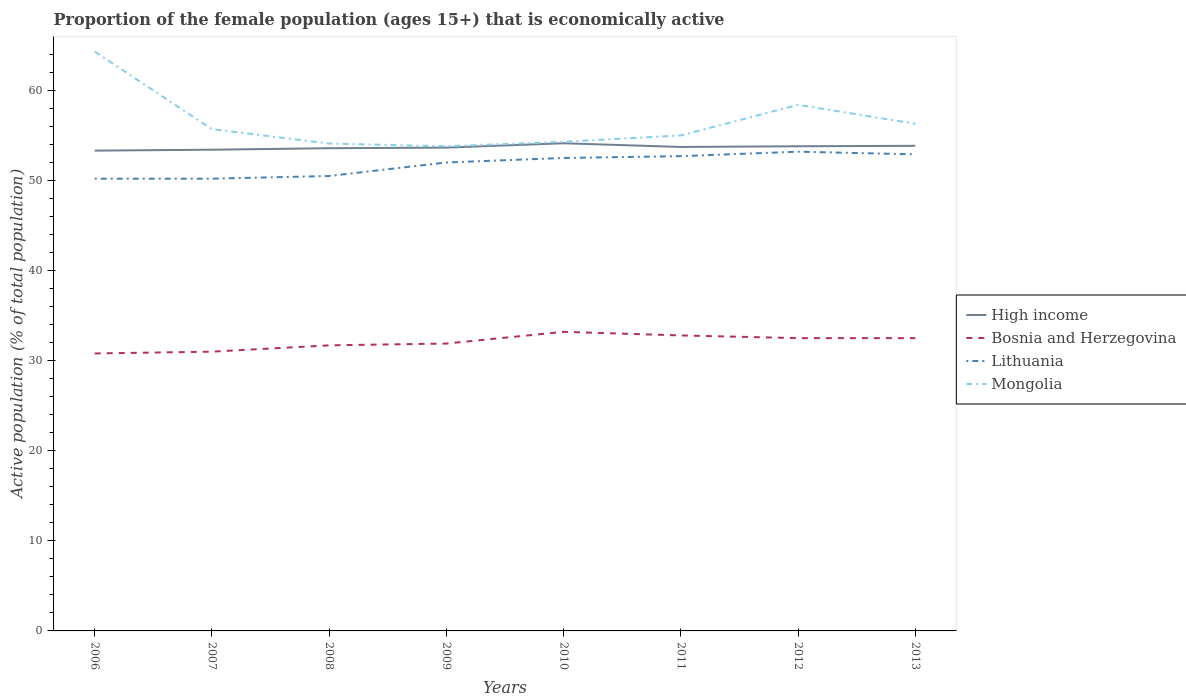How many different coloured lines are there?
Give a very brief answer. 4. Does the line corresponding to High income intersect with the line corresponding to Bosnia and Herzegovina?
Your answer should be compact. No. Across all years, what is the maximum proportion of the female population that is economically active in Bosnia and Herzegovina?
Provide a short and direct response. 30.8. In which year was the proportion of the female population that is economically active in Mongolia maximum?
Ensure brevity in your answer.  2009. What is the total proportion of the female population that is economically active in Mongolia in the graph?
Provide a succinct answer. -0.2. What is the difference between the highest and the second highest proportion of the female population that is economically active in High income?
Provide a succinct answer. 0.82. What is the difference between the highest and the lowest proportion of the female population that is economically active in High income?
Offer a very short reply. 4. Is the proportion of the female population that is economically active in Lithuania strictly greater than the proportion of the female population that is economically active in Bosnia and Herzegovina over the years?
Offer a terse response. No. How many lines are there?
Offer a terse response. 4. How many years are there in the graph?
Provide a short and direct response. 8. Where does the legend appear in the graph?
Make the answer very short. Center right. How many legend labels are there?
Keep it short and to the point. 4. How are the legend labels stacked?
Provide a short and direct response. Vertical. What is the title of the graph?
Ensure brevity in your answer.  Proportion of the female population (ages 15+) that is economically active. Does "Comoros" appear as one of the legend labels in the graph?
Your answer should be very brief. No. What is the label or title of the X-axis?
Keep it short and to the point. Years. What is the label or title of the Y-axis?
Your answer should be very brief. Active population (% of total population). What is the Active population (% of total population) of High income in 2006?
Offer a terse response. 53.31. What is the Active population (% of total population) in Bosnia and Herzegovina in 2006?
Offer a very short reply. 30.8. What is the Active population (% of total population) of Lithuania in 2006?
Your response must be concise. 50.2. What is the Active population (% of total population) of Mongolia in 2006?
Give a very brief answer. 64.3. What is the Active population (% of total population) in High income in 2007?
Provide a short and direct response. 53.42. What is the Active population (% of total population) in Lithuania in 2007?
Provide a short and direct response. 50.2. What is the Active population (% of total population) in Mongolia in 2007?
Your answer should be very brief. 55.7. What is the Active population (% of total population) in High income in 2008?
Your answer should be compact. 53.58. What is the Active population (% of total population) in Bosnia and Herzegovina in 2008?
Provide a short and direct response. 31.7. What is the Active population (% of total population) of Lithuania in 2008?
Your response must be concise. 50.5. What is the Active population (% of total population) in Mongolia in 2008?
Keep it short and to the point. 54.1. What is the Active population (% of total population) of High income in 2009?
Provide a succinct answer. 53.65. What is the Active population (% of total population) of Bosnia and Herzegovina in 2009?
Keep it short and to the point. 31.9. What is the Active population (% of total population) in Mongolia in 2009?
Keep it short and to the point. 53.8. What is the Active population (% of total population) in High income in 2010?
Provide a short and direct response. 54.13. What is the Active population (% of total population) of Bosnia and Herzegovina in 2010?
Your answer should be compact. 33.2. What is the Active population (% of total population) in Lithuania in 2010?
Keep it short and to the point. 52.5. What is the Active population (% of total population) of Mongolia in 2010?
Your answer should be very brief. 54.3. What is the Active population (% of total population) in High income in 2011?
Keep it short and to the point. 53.72. What is the Active population (% of total population) of Bosnia and Herzegovina in 2011?
Your response must be concise. 32.8. What is the Active population (% of total population) in Lithuania in 2011?
Your response must be concise. 52.7. What is the Active population (% of total population) of High income in 2012?
Make the answer very short. 53.8. What is the Active population (% of total population) of Bosnia and Herzegovina in 2012?
Offer a terse response. 32.5. What is the Active population (% of total population) of Lithuania in 2012?
Your answer should be very brief. 53.2. What is the Active population (% of total population) of Mongolia in 2012?
Offer a very short reply. 58.4. What is the Active population (% of total population) of High income in 2013?
Give a very brief answer. 53.85. What is the Active population (% of total population) of Bosnia and Herzegovina in 2013?
Keep it short and to the point. 32.5. What is the Active population (% of total population) in Lithuania in 2013?
Your response must be concise. 52.9. What is the Active population (% of total population) of Mongolia in 2013?
Make the answer very short. 56.3. Across all years, what is the maximum Active population (% of total population) in High income?
Make the answer very short. 54.13. Across all years, what is the maximum Active population (% of total population) in Bosnia and Herzegovina?
Ensure brevity in your answer.  33.2. Across all years, what is the maximum Active population (% of total population) in Lithuania?
Provide a succinct answer. 53.2. Across all years, what is the maximum Active population (% of total population) of Mongolia?
Your answer should be very brief. 64.3. Across all years, what is the minimum Active population (% of total population) in High income?
Your answer should be compact. 53.31. Across all years, what is the minimum Active population (% of total population) in Bosnia and Herzegovina?
Make the answer very short. 30.8. Across all years, what is the minimum Active population (% of total population) of Lithuania?
Ensure brevity in your answer.  50.2. Across all years, what is the minimum Active population (% of total population) of Mongolia?
Provide a succinct answer. 53.8. What is the total Active population (% of total population) in High income in the graph?
Your answer should be compact. 429.47. What is the total Active population (% of total population) of Bosnia and Herzegovina in the graph?
Provide a succinct answer. 256.4. What is the total Active population (% of total population) in Lithuania in the graph?
Offer a very short reply. 414.2. What is the total Active population (% of total population) of Mongolia in the graph?
Ensure brevity in your answer.  451.9. What is the difference between the Active population (% of total population) in High income in 2006 and that in 2007?
Offer a very short reply. -0.1. What is the difference between the Active population (% of total population) of Lithuania in 2006 and that in 2007?
Keep it short and to the point. 0. What is the difference between the Active population (% of total population) of High income in 2006 and that in 2008?
Provide a short and direct response. -0.27. What is the difference between the Active population (% of total population) of Bosnia and Herzegovina in 2006 and that in 2008?
Offer a terse response. -0.9. What is the difference between the Active population (% of total population) in Lithuania in 2006 and that in 2008?
Ensure brevity in your answer.  -0.3. What is the difference between the Active population (% of total population) of Mongolia in 2006 and that in 2008?
Offer a very short reply. 10.2. What is the difference between the Active population (% of total population) in High income in 2006 and that in 2009?
Your response must be concise. -0.34. What is the difference between the Active population (% of total population) in Bosnia and Herzegovina in 2006 and that in 2009?
Keep it short and to the point. -1.1. What is the difference between the Active population (% of total population) in Lithuania in 2006 and that in 2009?
Your response must be concise. -1.8. What is the difference between the Active population (% of total population) of High income in 2006 and that in 2010?
Keep it short and to the point. -0.82. What is the difference between the Active population (% of total population) of Bosnia and Herzegovina in 2006 and that in 2010?
Make the answer very short. -2.4. What is the difference between the Active population (% of total population) of Mongolia in 2006 and that in 2010?
Give a very brief answer. 10. What is the difference between the Active population (% of total population) in High income in 2006 and that in 2011?
Make the answer very short. -0.41. What is the difference between the Active population (% of total population) of Lithuania in 2006 and that in 2011?
Make the answer very short. -2.5. What is the difference between the Active population (% of total population) of Mongolia in 2006 and that in 2011?
Provide a succinct answer. 9.3. What is the difference between the Active population (% of total population) of High income in 2006 and that in 2012?
Ensure brevity in your answer.  -0.48. What is the difference between the Active population (% of total population) in Bosnia and Herzegovina in 2006 and that in 2012?
Ensure brevity in your answer.  -1.7. What is the difference between the Active population (% of total population) in High income in 2006 and that in 2013?
Offer a very short reply. -0.54. What is the difference between the Active population (% of total population) of Mongolia in 2006 and that in 2013?
Your answer should be very brief. 8. What is the difference between the Active population (% of total population) of High income in 2007 and that in 2008?
Your answer should be compact. -0.16. What is the difference between the Active population (% of total population) of Bosnia and Herzegovina in 2007 and that in 2008?
Give a very brief answer. -0.7. What is the difference between the Active population (% of total population) of Lithuania in 2007 and that in 2008?
Your answer should be very brief. -0.3. What is the difference between the Active population (% of total population) in High income in 2007 and that in 2009?
Offer a terse response. -0.23. What is the difference between the Active population (% of total population) of Bosnia and Herzegovina in 2007 and that in 2009?
Give a very brief answer. -0.9. What is the difference between the Active population (% of total population) in Lithuania in 2007 and that in 2009?
Ensure brevity in your answer.  -1.8. What is the difference between the Active population (% of total population) in High income in 2007 and that in 2010?
Offer a terse response. -0.71. What is the difference between the Active population (% of total population) of Bosnia and Herzegovina in 2007 and that in 2010?
Make the answer very short. -2.2. What is the difference between the Active population (% of total population) in Lithuania in 2007 and that in 2010?
Offer a very short reply. -2.3. What is the difference between the Active population (% of total population) in Mongolia in 2007 and that in 2010?
Keep it short and to the point. 1.4. What is the difference between the Active population (% of total population) in High income in 2007 and that in 2011?
Offer a terse response. -0.3. What is the difference between the Active population (% of total population) in Lithuania in 2007 and that in 2011?
Ensure brevity in your answer.  -2.5. What is the difference between the Active population (% of total population) in High income in 2007 and that in 2012?
Offer a terse response. -0.38. What is the difference between the Active population (% of total population) of High income in 2007 and that in 2013?
Your answer should be very brief. -0.43. What is the difference between the Active population (% of total population) in High income in 2008 and that in 2009?
Offer a very short reply. -0.07. What is the difference between the Active population (% of total population) of Bosnia and Herzegovina in 2008 and that in 2009?
Ensure brevity in your answer.  -0.2. What is the difference between the Active population (% of total population) of Lithuania in 2008 and that in 2009?
Your response must be concise. -1.5. What is the difference between the Active population (% of total population) in High income in 2008 and that in 2010?
Offer a terse response. -0.55. What is the difference between the Active population (% of total population) in Bosnia and Herzegovina in 2008 and that in 2010?
Provide a succinct answer. -1.5. What is the difference between the Active population (% of total population) in Lithuania in 2008 and that in 2010?
Make the answer very short. -2. What is the difference between the Active population (% of total population) of High income in 2008 and that in 2011?
Your answer should be very brief. -0.14. What is the difference between the Active population (% of total population) of Bosnia and Herzegovina in 2008 and that in 2011?
Your response must be concise. -1.1. What is the difference between the Active population (% of total population) of Lithuania in 2008 and that in 2011?
Keep it short and to the point. -2.2. What is the difference between the Active population (% of total population) of Mongolia in 2008 and that in 2011?
Your answer should be compact. -0.9. What is the difference between the Active population (% of total population) of High income in 2008 and that in 2012?
Offer a very short reply. -0.22. What is the difference between the Active population (% of total population) of High income in 2008 and that in 2013?
Offer a terse response. -0.27. What is the difference between the Active population (% of total population) in Bosnia and Herzegovina in 2008 and that in 2013?
Offer a terse response. -0.8. What is the difference between the Active population (% of total population) of High income in 2009 and that in 2010?
Your answer should be very brief. -0.48. What is the difference between the Active population (% of total population) in Mongolia in 2009 and that in 2010?
Give a very brief answer. -0.5. What is the difference between the Active population (% of total population) of High income in 2009 and that in 2011?
Make the answer very short. -0.07. What is the difference between the Active population (% of total population) of Bosnia and Herzegovina in 2009 and that in 2011?
Give a very brief answer. -0.9. What is the difference between the Active population (% of total population) in Lithuania in 2009 and that in 2011?
Offer a very short reply. -0.7. What is the difference between the Active population (% of total population) in High income in 2009 and that in 2012?
Your response must be concise. -0.15. What is the difference between the Active population (% of total population) of Mongolia in 2009 and that in 2012?
Your answer should be compact. -4.6. What is the difference between the Active population (% of total population) of High income in 2009 and that in 2013?
Your answer should be compact. -0.2. What is the difference between the Active population (% of total population) in Bosnia and Herzegovina in 2009 and that in 2013?
Ensure brevity in your answer.  -0.6. What is the difference between the Active population (% of total population) of High income in 2010 and that in 2011?
Provide a succinct answer. 0.41. What is the difference between the Active population (% of total population) in Bosnia and Herzegovina in 2010 and that in 2011?
Give a very brief answer. 0.4. What is the difference between the Active population (% of total population) in Lithuania in 2010 and that in 2011?
Your answer should be very brief. -0.2. What is the difference between the Active population (% of total population) in High income in 2010 and that in 2012?
Offer a very short reply. 0.33. What is the difference between the Active population (% of total population) of Bosnia and Herzegovina in 2010 and that in 2012?
Give a very brief answer. 0.7. What is the difference between the Active population (% of total population) of Mongolia in 2010 and that in 2012?
Make the answer very short. -4.1. What is the difference between the Active population (% of total population) in High income in 2010 and that in 2013?
Ensure brevity in your answer.  0.28. What is the difference between the Active population (% of total population) of Bosnia and Herzegovina in 2010 and that in 2013?
Keep it short and to the point. 0.7. What is the difference between the Active population (% of total population) in High income in 2011 and that in 2012?
Make the answer very short. -0.08. What is the difference between the Active population (% of total population) in Mongolia in 2011 and that in 2012?
Provide a short and direct response. -3.4. What is the difference between the Active population (% of total population) of High income in 2011 and that in 2013?
Your response must be concise. -0.13. What is the difference between the Active population (% of total population) of Bosnia and Herzegovina in 2011 and that in 2013?
Offer a very short reply. 0.3. What is the difference between the Active population (% of total population) of Lithuania in 2011 and that in 2013?
Make the answer very short. -0.2. What is the difference between the Active population (% of total population) in Mongolia in 2011 and that in 2013?
Your answer should be compact. -1.3. What is the difference between the Active population (% of total population) of High income in 2012 and that in 2013?
Your answer should be compact. -0.05. What is the difference between the Active population (% of total population) in Bosnia and Herzegovina in 2012 and that in 2013?
Your answer should be compact. 0. What is the difference between the Active population (% of total population) of Lithuania in 2012 and that in 2013?
Offer a very short reply. 0.3. What is the difference between the Active population (% of total population) of High income in 2006 and the Active population (% of total population) of Bosnia and Herzegovina in 2007?
Ensure brevity in your answer.  22.31. What is the difference between the Active population (% of total population) of High income in 2006 and the Active population (% of total population) of Lithuania in 2007?
Your response must be concise. 3.11. What is the difference between the Active population (% of total population) in High income in 2006 and the Active population (% of total population) in Mongolia in 2007?
Make the answer very short. -2.39. What is the difference between the Active population (% of total population) of Bosnia and Herzegovina in 2006 and the Active population (% of total population) of Lithuania in 2007?
Give a very brief answer. -19.4. What is the difference between the Active population (% of total population) in Bosnia and Herzegovina in 2006 and the Active population (% of total population) in Mongolia in 2007?
Ensure brevity in your answer.  -24.9. What is the difference between the Active population (% of total population) in High income in 2006 and the Active population (% of total population) in Bosnia and Herzegovina in 2008?
Make the answer very short. 21.61. What is the difference between the Active population (% of total population) in High income in 2006 and the Active population (% of total population) in Lithuania in 2008?
Provide a succinct answer. 2.81. What is the difference between the Active population (% of total population) in High income in 2006 and the Active population (% of total population) in Mongolia in 2008?
Ensure brevity in your answer.  -0.79. What is the difference between the Active population (% of total population) of Bosnia and Herzegovina in 2006 and the Active population (% of total population) of Lithuania in 2008?
Your answer should be compact. -19.7. What is the difference between the Active population (% of total population) in Bosnia and Herzegovina in 2006 and the Active population (% of total population) in Mongolia in 2008?
Make the answer very short. -23.3. What is the difference between the Active population (% of total population) of Lithuania in 2006 and the Active population (% of total population) of Mongolia in 2008?
Give a very brief answer. -3.9. What is the difference between the Active population (% of total population) of High income in 2006 and the Active population (% of total population) of Bosnia and Herzegovina in 2009?
Offer a very short reply. 21.41. What is the difference between the Active population (% of total population) in High income in 2006 and the Active population (% of total population) in Lithuania in 2009?
Provide a succinct answer. 1.31. What is the difference between the Active population (% of total population) in High income in 2006 and the Active population (% of total population) in Mongolia in 2009?
Ensure brevity in your answer.  -0.49. What is the difference between the Active population (% of total population) in Bosnia and Herzegovina in 2006 and the Active population (% of total population) in Lithuania in 2009?
Provide a short and direct response. -21.2. What is the difference between the Active population (% of total population) in High income in 2006 and the Active population (% of total population) in Bosnia and Herzegovina in 2010?
Provide a short and direct response. 20.11. What is the difference between the Active population (% of total population) in High income in 2006 and the Active population (% of total population) in Lithuania in 2010?
Provide a short and direct response. 0.81. What is the difference between the Active population (% of total population) in High income in 2006 and the Active population (% of total population) in Mongolia in 2010?
Your answer should be compact. -0.99. What is the difference between the Active population (% of total population) in Bosnia and Herzegovina in 2006 and the Active population (% of total population) in Lithuania in 2010?
Ensure brevity in your answer.  -21.7. What is the difference between the Active population (% of total population) of Bosnia and Herzegovina in 2006 and the Active population (% of total population) of Mongolia in 2010?
Ensure brevity in your answer.  -23.5. What is the difference between the Active population (% of total population) in Lithuania in 2006 and the Active population (% of total population) in Mongolia in 2010?
Provide a succinct answer. -4.1. What is the difference between the Active population (% of total population) of High income in 2006 and the Active population (% of total population) of Bosnia and Herzegovina in 2011?
Make the answer very short. 20.51. What is the difference between the Active population (% of total population) of High income in 2006 and the Active population (% of total population) of Lithuania in 2011?
Keep it short and to the point. 0.61. What is the difference between the Active population (% of total population) of High income in 2006 and the Active population (% of total population) of Mongolia in 2011?
Your answer should be compact. -1.69. What is the difference between the Active population (% of total population) of Bosnia and Herzegovina in 2006 and the Active population (% of total population) of Lithuania in 2011?
Offer a terse response. -21.9. What is the difference between the Active population (% of total population) of Bosnia and Herzegovina in 2006 and the Active population (% of total population) of Mongolia in 2011?
Keep it short and to the point. -24.2. What is the difference between the Active population (% of total population) of High income in 2006 and the Active population (% of total population) of Bosnia and Herzegovina in 2012?
Provide a succinct answer. 20.81. What is the difference between the Active population (% of total population) of High income in 2006 and the Active population (% of total population) of Lithuania in 2012?
Give a very brief answer. 0.11. What is the difference between the Active population (% of total population) in High income in 2006 and the Active population (% of total population) in Mongolia in 2012?
Your answer should be very brief. -5.09. What is the difference between the Active population (% of total population) of Bosnia and Herzegovina in 2006 and the Active population (% of total population) of Lithuania in 2012?
Your response must be concise. -22.4. What is the difference between the Active population (% of total population) of Bosnia and Herzegovina in 2006 and the Active population (% of total population) of Mongolia in 2012?
Provide a succinct answer. -27.6. What is the difference between the Active population (% of total population) of High income in 2006 and the Active population (% of total population) of Bosnia and Herzegovina in 2013?
Your response must be concise. 20.81. What is the difference between the Active population (% of total population) of High income in 2006 and the Active population (% of total population) of Lithuania in 2013?
Keep it short and to the point. 0.41. What is the difference between the Active population (% of total population) of High income in 2006 and the Active population (% of total population) of Mongolia in 2013?
Offer a very short reply. -2.99. What is the difference between the Active population (% of total population) of Bosnia and Herzegovina in 2006 and the Active population (% of total population) of Lithuania in 2013?
Your answer should be very brief. -22.1. What is the difference between the Active population (% of total population) in Bosnia and Herzegovina in 2006 and the Active population (% of total population) in Mongolia in 2013?
Offer a terse response. -25.5. What is the difference between the Active population (% of total population) in Lithuania in 2006 and the Active population (% of total population) in Mongolia in 2013?
Your response must be concise. -6.1. What is the difference between the Active population (% of total population) of High income in 2007 and the Active population (% of total population) of Bosnia and Herzegovina in 2008?
Make the answer very short. 21.72. What is the difference between the Active population (% of total population) of High income in 2007 and the Active population (% of total population) of Lithuania in 2008?
Make the answer very short. 2.92. What is the difference between the Active population (% of total population) in High income in 2007 and the Active population (% of total population) in Mongolia in 2008?
Your answer should be very brief. -0.68. What is the difference between the Active population (% of total population) in Bosnia and Herzegovina in 2007 and the Active population (% of total population) in Lithuania in 2008?
Your response must be concise. -19.5. What is the difference between the Active population (% of total population) in Bosnia and Herzegovina in 2007 and the Active population (% of total population) in Mongolia in 2008?
Give a very brief answer. -23.1. What is the difference between the Active population (% of total population) of Lithuania in 2007 and the Active population (% of total population) of Mongolia in 2008?
Your response must be concise. -3.9. What is the difference between the Active population (% of total population) in High income in 2007 and the Active population (% of total population) in Bosnia and Herzegovina in 2009?
Make the answer very short. 21.52. What is the difference between the Active population (% of total population) in High income in 2007 and the Active population (% of total population) in Lithuania in 2009?
Offer a terse response. 1.42. What is the difference between the Active population (% of total population) in High income in 2007 and the Active population (% of total population) in Mongolia in 2009?
Offer a terse response. -0.38. What is the difference between the Active population (% of total population) of Bosnia and Herzegovina in 2007 and the Active population (% of total population) of Mongolia in 2009?
Provide a succinct answer. -22.8. What is the difference between the Active population (% of total population) in High income in 2007 and the Active population (% of total population) in Bosnia and Herzegovina in 2010?
Your response must be concise. 20.22. What is the difference between the Active population (% of total population) in High income in 2007 and the Active population (% of total population) in Lithuania in 2010?
Offer a very short reply. 0.92. What is the difference between the Active population (% of total population) in High income in 2007 and the Active population (% of total population) in Mongolia in 2010?
Your answer should be compact. -0.88. What is the difference between the Active population (% of total population) in Bosnia and Herzegovina in 2007 and the Active population (% of total population) in Lithuania in 2010?
Your response must be concise. -21.5. What is the difference between the Active population (% of total population) in Bosnia and Herzegovina in 2007 and the Active population (% of total population) in Mongolia in 2010?
Provide a succinct answer. -23.3. What is the difference between the Active population (% of total population) of Lithuania in 2007 and the Active population (% of total population) of Mongolia in 2010?
Give a very brief answer. -4.1. What is the difference between the Active population (% of total population) of High income in 2007 and the Active population (% of total population) of Bosnia and Herzegovina in 2011?
Offer a very short reply. 20.62. What is the difference between the Active population (% of total population) in High income in 2007 and the Active population (% of total population) in Lithuania in 2011?
Make the answer very short. 0.72. What is the difference between the Active population (% of total population) in High income in 2007 and the Active population (% of total population) in Mongolia in 2011?
Keep it short and to the point. -1.58. What is the difference between the Active population (% of total population) in Bosnia and Herzegovina in 2007 and the Active population (% of total population) in Lithuania in 2011?
Give a very brief answer. -21.7. What is the difference between the Active population (% of total population) of Bosnia and Herzegovina in 2007 and the Active population (% of total population) of Mongolia in 2011?
Offer a very short reply. -24. What is the difference between the Active population (% of total population) in High income in 2007 and the Active population (% of total population) in Bosnia and Herzegovina in 2012?
Give a very brief answer. 20.92. What is the difference between the Active population (% of total population) in High income in 2007 and the Active population (% of total population) in Lithuania in 2012?
Your answer should be very brief. 0.22. What is the difference between the Active population (% of total population) in High income in 2007 and the Active population (% of total population) in Mongolia in 2012?
Ensure brevity in your answer.  -4.98. What is the difference between the Active population (% of total population) in Bosnia and Herzegovina in 2007 and the Active population (% of total population) in Lithuania in 2012?
Your answer should be very brief. -22.2. What is the difference between the Active population (% of total population) of Bosnia and Herzegovina in 2007 and the Active population (% of total population) of Mongolia in 2012?
Your response must be concise. -27.4. What is the difference between the Active population (% of total population) of High income in 2007 and the Active population (% of total population) of Bosnia and Herzegovina in 2013?
Provide a succinct answer. 20.92. What is the difference between the Active population (% of total population) in High income in 2007 and the Active population (% of total population) in Lithuania in 2013?
Offer a very short reply. 0.52. What is the difference between the Active population (% of total population) in High income in 2007 and the Active population (% of total population) in Mongolia in 2013?
Make the answer very short. -2.88. What is the difference between the Active population (% of total population) in Bosnia and Herzegovina in 2007 and the Active population (% of total population) in Lithuania in 2013?
Offer a very short reply. -21.9. What is the difference between the Active population (% of total population) of Bosnia and Herzegovina in 2007 and the Active population (% of total population) of Mongolia in 2013?
Your response must be concise. -25.3. What is the difference between the Active population (% of total population) in High income in 2008 and the Active population (% of total population) in Bosnia and Herzegovina in 2009?
Provide a short and direct response. 21.68. What is the difference between the Active population (% of total population) of High income in 2008 and the Active population (% of total population) of Lithuania in 2009?
Offer a very short reply. 1.58. What is the difference between the Active population (% of total population) in High income in 2008 and the Active population (% of total population) in Mongolia in 2009?
Keep it short and to the point. -0.22. What is the difference between the Active population (% of total population) of Bosnia and Herzegovina in 2008 and the Active population (% of total population) of Lithuania in 2009?
Offer a terse response. -20.3. What is the difference between the Active population (% of total population) of Bosnia and Herzegovina in 2008 and the Active population (% of total population) of Mongolia in 2009?
Ensure brevity in your answer.  -22.1. What is the difference between the Active population (% of total population) in Lithuania in 2008 and the Active population (% of total population) in Mongolia in 2009?
Make the answer very short. -3.3. What is the difference between the Active population (% of total population) in High income in 2008 and the Active population (% of total population) in Bosnia and Herzegovina in 2010?
Offer a very short reply. 20.38. What is the difference between the Active population (% of total population) of High income in 2008 and the Active population (% of total population) of Lithuania in 2010?
Give a very brief answer. 1.08. What is the difference between the Active population (% of total population) of High income in 2008 and the Active population (% of total population) of Mongolia in 2010?
Give a very brief answer. -0.72. What is the difference between the Active population (% of total population) of Bosnia and Herzegovina in 2008 and the Active population (% of total population) of Lithuania in 2010?
Provide a short and direct response. -20.8. What is the difference between the Active population (% of total population) of Bosnia and Herzegovina in 2008 and the Active population (% of total population) of Mongolia in 2010?
Provide a short and direct response. -22.6. What is the difference between the Active population (% of total population) in Lithuania in 2008 and the Active population (% of total population) in Mongolia in 2010?
Keep it short and to the point. -3.8. What is the difference between the Active population (% of total population) in High income in 2008 and the Active population (% of total population) in Bosnia and Herzegovina in 2011?
Your answer should be compact. 20.78. What is the difference between the Active population (% of total population) in High income in 2008 and the Active population (% of total population) in Lithuania in 2011?
Give a very brief answer. 0.88. What is the difference between the Active population (% of total population) of High income in 2008 and the Active population (% of total population) of Mongolia in 2011?
Give a very brief answer. -1.42. What is the difference between the Active population (% of total population) in Bosnia and Herzegovina in 2008 and the Active population (% of total population) in Mongolia in 2011?
Offer a very short reply. -23.3. What is the difference between the Active population (% of total population) in High income in 2008 and the Active population (% of total population) in Bosnia and Herzegovina in 2012?
Provide a short and direct response. 21.08. What is the difference between the Active population (% of total population) in High income in 2008 and the Active population (% of total population) in Lithuania in 2012?
Provide a succinct answer. 0.38. What is the difference between the Active population (% of total population) of High income in 2008 and the Active population (% of total population) of Mongolia in 2012?
Offer a terse response. -4.82. What is the difference between the Active population (% of total population) of Bosnia and Herzegovina in 2008 and the Active population (% of total population) of Lithuania in 2012?
Your answer should be very brief. -21.5. What is the difference between the Active population (% of total population) in Bosnia and Herzegovina in 2008 and the Active population (% of total population) in Mongolia in 2012?
Your response must be concise. -26.7. What is the difference between the Active population (% of total population) in High income in 2008 and the Active population (% of total population) in Bosnia and Herzegovina in 2013?
Keep it short and to the point. 21.08. What is the difference between the Active population (% of total population) in High income in 2008 and the Active population (% of total population) in Lithuania in 2013?
Your answer should be compact. 0.68. What is the difference between the Active population (% of total population) of High income in 2008 and the Active population (% of total population) of Mongolia in 2013?
Make the answer very short. -2.72. What is the difference between the Active population (% of total population) of Bosnia and Herzegovina in 2008 and the Active population (% of total population) of Lithuania in 2013?
Give a very brief answer. -21.2. What is the difference between the Active population (% of total population) of Bosnia and Herzegovina in 2008 and the Active population (% of total population) of Mongolia in 2013?
Your response must be concise. -24.6. What is the difference between the Active population (% of total population) in High income in 2009 and the Active population (% of total population) in Bosnia and Herzegovina in 2010?
Your answer should be compact. 20.45. What is the difference between the Active population (% of total population) in High income in 2009 and the Active population (% of total population) in Lithuania in 2010?
Your answer should be compact. 1.15. What is the difference between the Active population (% of total population) in High income in 2009 and the Active population (% of total population) in Mongolia in 2010?
Make the answer very short. -0.65. What is the difference between the Active population (% of total population) of Bosnia and Herzegovina in 2009 and the Active population (% of total population) of Lithuania in 2010?
Provide a succinct answer. -20.6. What is the difference between the Active population (% of total population) of Bosnia and Herzegovina in 2009 and the Active population (% of total population) of Mongolia in 2010?
Your answer should be very brief. -22.4. What is the difference between the Active population (% of total population) of Lithuania in 2009 and the Active population (% of total population) of Mongolia in 2010?
Provide a succinct answer. -2.3. What is the difference between the Active population (% of total population) of High income in 2009 and the Active population (% of total population) of Bosnia and Herzegovina in 2011?
Give a very brief answer. 20.85. What is the difference between the Active population (% of total population) in High income in 2009 and the Active population (% of total population) in Lithuania in 2011?
Keep it short and to the point. 0.95. What is the difference between the Active population (% of total population) in High income in 2009 and the Active population (% of total population) in Mongolia in 2011?
Offer a very short reply. -1.35. What is the difference between the Active population (% of total population) of Bosnia and Herzegovina in 2009 and the Active population (% of total population) of Lithuania in 2011?
Give a very brief answer. -20.8. What is the difference between the Active population (% of total population) in Bosnia and Herzegovina in 2009 and the Active population (% of total population) in Mongolia in 2011?
Your answer should be very brief. -23.1. What is the difference between the Active population (% of total population) of Lithuania in 2009 and the Active population (% of total population) of Mongolia in 2011?
Your answer should be very brief. -3. What is the difference between the Active population (% of total population) of High income in 2009 and the Active population (% of total population) of Bosnia and Herzegovina in 2012?
Keep it short and to the point. 21.15. What is the difference between the Active population (% of total population) of High income in 2009 and the Active population (% of total population) of Lithuania in 2012?
Make the answer very short. 0.45. What is the difference between the Active population (% of total population) in High income in 2009 and the Active population (% of total population) in Mongolia in 2012?
Your response must be concise. -4.75. What is the difference between the Active population (% of total population) of Bosnia and Herzegovina in 2009 and the Active population (% of total population) of Lithuania in 2012?
Ensure brevity in your answer.  -21.3. What is the difference between the Active population (% of total population) in Bosnia and Herzegovina in 2009 and the Active population (% of total population) in Mongolia in 2012?
Make the answer very short. -26.5. What is the difference between the Active population (% of total population) in Lithuania in 2009 and the Active population (% of total population) in Mongolia in 2012?
Provide a short and direct response. -6.4. What is the difference between the Active population (% of total population) of High income in 2009 and the Active population (% of total population) of Bosnia and Herzegovina in 2013?
Make the answer very short. 21.15. What is the difference between the Active population (% of total population) of High income in 2009 and the Active population (% of total population) of Lithuania in 2013?
Ensure brevity in your answer.  0.75. What is the difference between the Active population (% of total population) of High income in 2009 and the Active population (% of total population) of Mongolia in 2013?
Offer a terse response. -2.65. What is the difference between the Active population (% of total population) of Bosnia and Herzegovina in 2009 and the Active population (% of total population) of Mongolia in 2013?
Give a very brief answer. -24.4. What is the difference between the Active population (% of total population) in High income in 2010 and the Active population (% of total population) in Bosnia and Herzegovina in 2011?
Offer a very short reply. 21.33. What is the difference between the Active population (% of total population) in High income in 2010 and the Active population (% of total population) in Lithuania in 2011?
Ensure brevity in your answer.  1.43. What is the difference between the Active population (% of total population) of High income in 2010 and the Active population (% of total population) of Mongolia in 2011?
Provide a short and direct response. -0.87. What is the difference between the Active population (% of total population) in Bosnia and Herzegovina in 2010 and the Active population (% of total population) in Lithuania in 2011?
Offer a terse response. -19.5. What is the difference between the Active population (% of total population) in Bosnia and Herzegovina in 2010 and the Active population (% of total population) in Mongolia in 2011?
Your answer should be compact. -21.8. What is the difference between the Active population (% of total population) of Lithuania in 2010 and the Active population (% of total population) of Mongolia in 2011?
Offer a very short reply. -2.5. What is the difference between the Active population (% of total population) of High income in 2010 and the Active population (% of total population) of Bosnia and Herzegovina in 2012?
Your answer should be very brief. 21.63. What is the difference between the Active population (% of total population) of High income in 2010 and the Active population (% of total population) of Lithuania in 2012?
Your response must be concise. 0.93. What is the difference between the Active population (% of total population) of High income in 2010 and the Active population (% of total population) of Mongolia in 2012?
Provide a succinct answer. -4.27. What is the difference between the Active population (% of total population) of Bosnia and Herzegovina in 2010 and the Active population (% of total population) of Lithuania in 2012?
Offer a very short reply. -20. What is the difference between the Active population (% of total population) in Bosnia and Herzegovina in 2010 and the Active population (% of total population) in Mongolia in 2012?
Offer a terse response. -25.2. What is the difference between the Active population (% of total population) of High income in 2010 and the Active population (% of total population) of Bosnia and Herzegovina in 2013?
Your answer should be compact. 21.63. What is the difference between the Active population (% of total population) of High income in 2010 and the Active population (% of total population) of Lithuania in 2013?
Keep it short and to the point. 1.23. What is the difference between the Active population (% of total population) of High income in 2010 and the Active population (% of total population) of Mongolia in 2013?
Give a very brief answer. -2.17. What is the difference between the Active population (% of total population) of Bosnia and Herzegovina in 2010 and the Active population (% of total population) of Lithuania in 2013?
Offer a very short reply. -19.7. What is the difference between the Active population (% of total population) in Bosnia and Herzegovina in 2010 and the Active population (% of total population) in Mongolia in 2013?
Make the answer very short. -23.1. What is the difference between the Active population (% of total population) in Lithuania in 2010 and the Active population (% of total population) in Mongolia in 2013?
Keep it short and to the point. -3.8. What is the difference between the Active population (% of total population) in High income in 2011 and the Active population (% of total population) in Bosnia and Herzegovina in 2012?
Provide a succinct answer. 21.22. What is the difference between the Active population (% of total population) in High income in 2011 and the Active population (% of total population) in Lithuania in 2012?
Your answer should be compact. 0.52. What is the difference between the Active population (% of total population) in High income in 2011 and the Active population (% of total population) in Mongolia in 2012?
Make the answer very short. -4.68. What is the difference between the Active population (% of total population) of Bosnia and Herzegovina in 2011 and the Active population (% of total population) of Lithuania in 2012?
Offer a terse response. -20.4. What is the difference between the Active population (% of total population) in Bosnia and Herzegovina in 2011 and the Active population (% of total population) in Mongolia in 2012?
Give a very brief answer. -25.6. What is the difference between the Active population (% of total population) in High income in 2011 and the Active population (% of total population) in Bosnia and Herzegovina in 2013?
Ensure brevity in your answer.  21.22. What is the difference between the Active population (% of total population) in High income in 2011 and the Active population (% of total population) in Lithuania in 2013?
Ensure brevity in your answer.  0.82. What is the difference between the Active population (% of total population) of High income in 2011 and the Active population (% of total population) of Mongolia in 2013?
Keep it short and to the point. -2.58. What is the difference between the Active population (% of total population) in Bosnia and Herzegovina in 2011 and the Active population (% of total population) in Lithuania in 2013?
Provide a short and direct response. -20.1. What is the difference between the Active population (% of total population) of Bosnia and Herzegovina in 2011 and the Active population (% of total population) of Mongolia in 2013?
Keep it short and to the point. -23.5. What is the difference between the Active population (% of total population) of Lithuania in 2011 and the Active population (% of total population) of Mongolia in 2013?
Provide a short and direct response. -3.6. What is the difference between the Active population (% of total population) in High income in 2012 and the Active population (% of total population) in Bosnia and Herzegovina in 2013?
Provide a short and direct response. 21.3. What is the difference between the Active population (% of total population) of High income in 2012 and the Active population (% of total population) of Lithuania in 2013?
Provide a succinct answer. 0.9. What is the difference between the Active population (% of total population) of High income in 2012 and the Active population (% of total population) of Mongolia in 2013?
Give a very brief answer. -2.5. What is the difference between the Active population (% of total population) of Bosnia and Herzegovina in 2012 and the Active population (% of total population) of Lithuania in 2013?
Provide a succinct answer. -20.4. What is the difference between the Active population (% of total population) in Bosnia and Herzegovina in 2012 and the Active population (% of total population) in Mongolia in 2013?
Your response must be concise. -23.8. What is the average Active population (% of total population) in High income per year?
Offer a terse response. 53.68. What is the average Active population (% of total population) of Bosnia and Herzegovina per year?
Ensure brevity in your answer.  32.05. What is the average Active population (% of total population) in Lithuania per year?
Your response must be concise. 51.77. What is the average Active population (% of total population) in Mongolia per year?
Offer a very short reply. 56.49. In the year 2006, what is the difference between the Active population (% of total population) of High income and Active population (% of total population) of Bosnia and Herzegovina?
Provide a short and direct response. 22.51. In the year 2006, what is the difference between the Active population (% of total population) of High income and Active population (% of total population) of Lithuania?
Your answer should be compact. 3.11. In the year 2006, what is the difference between the Active population (% of total population) of High income and Active population (% of total population) of Mongolia?
Give a very brief answer. -10.99. In the year 2006, what is the difference between the Active population (% of total population) of Bosnia and Herzegovina and Active population (% of total population) of Lithuania?
Provide a short and direct response. -19.4. In the year 2006, what is the difference between the Active population (% of total population) in Bosnia and Herzegovina and Active population (% of total population) in Mongolia?
Make the answer very short. -33.5. In the year 2006, what is the difference between the Active population (% of total population) in Lithuania and Active population (% of total population) in Mongolia?
Your response must be concise. -14.1. In the year 2007, what is the difference between the Active population (% of total population) of High income and Active population (% of total population) of Bosnia and Herzegovina?
Your response must be concise. 22.42. In the year 2007, what is the difference between the Active population (% of total population) in High income and Active population (% of total population) in Lithuania?
Your answer should be compact. 3.22. In the year 2007, what is the difference between the Active population (% of total population) in High income and Active population (% of total population) in Mongolia?
Offer a very short reply. -2.28. In the year 2007, what is the difference between the Active population (% of total population) in Bosnia and Herzegovina and Active population (% of total population) in Lithuania?
Offer a terse response. -19.2. In the year 2007, what is the difference between the Active population (% of total population) in Bosnia and Herzegovina and Active population (% of total population) in Mongolia?
Give a very brief answer. -24.7. In the year 2008, what is the difference between the Active population (% of total population) in High income and Active population (% of total population) in Bosnia and Herzegovina?
Your answer should be compact. 21.88. In the year 2008, what is the difference between the Active population (% of total population) of High income and Active population (% of total population) of Lithuania?
Ensure brevity in your answer.  3.08. In the year 2008, what is the difference between the Active population (% of total population) in High income and Active population (% of total population) in Mongolia?
Make the answer very short. -0.52. In the year 2008, what is the difference between the Active population (% of total population) in Bosnia and Herzegovina and Active population (% of total population) in Lithuania?
Ensure brevity in your answer.  -18.8. In the year 2008, what is the difference between the Active population (% of total population) in Bosnia and Herzegovina and Active population (% of total population) in Mongolia?
Provide a short and direct response. -22.4. In the year 2008, what is the difference between the Active population (% of total population) in Lithuania and Active population (% of total population) in Mongolia?
Make the answer very short. -3.6. In the year 2009, what is the difference between the Active population (% of total population) in High income and Active population (% of total population) in Bosnia and Herzegovina?
Keep it short and to the point. 21.75. In the year 2009, what is the difference between the Active population (% of total population) of High income and Active population (% of total population) of Lithuania?
Offer a terse response. 1.65. In the year 2009, what is the difference between the Active population (% of total population) of High income and Active population (% of total population) of Mongolia?
Keep it short and to the point. -0.15. In the year 2009, what is the difference between the Active population (% of total population) in Bosnia and Herzegovina and Active population (% of total population) in Lithuania?
Provide a short and direct response. -20.1. In the year 2009, what is the difference between the Active population (% of total population) of Bosnia and Herzegovina and Active population (% of total population) of Mongolia?
Offer a very short reply. -21.9. In the year 2009, what is the difference between the Active population (% of total population) in Lithuania and Active population (% of total population) in Mongolia?
Offer a terse response. -1.8. In the year 2010, what is the difference between the Active population (% of total population) of High income and Active population (% of total population) of Bosnia and Herzegovina?
Provide a short and direct response. 20.93. In the year 2010, what is the difference between the Active population (% of total population) in High income and Active population (% of total population) in Lithuania?
Your answer should be compact. 1.63. In the year 2010, what is the difference between the Active population (% of total population) in High income and Active population (% of total population) in Mongolia?
Make the answer very short. -0.17. In the year 2010, what is the difference between the Active population (% of total population) of Bosnia and Herzegovina and Active population (% of total population) of Lithuania?
Ensure brevity in your answer.  -19.3. In the year 2010, what is the difference between the Active population (% of total population) of Bosnia and Herzegovina and Active population (% of total population) of Mongolia?
Keep it short and to the point. -21.1. In the year 2011, what is the difference between the Active population (% of total population) in High income and Active population (% of total population) in Bosnia and Herzegovina?
Ensure brevity in your answer.  20.92. In the year 2011, what is the difference between the Active population (% of total population) of High income and Active population (% of total population) of Lithuania?
Make the answer very short. 1.02. In the year 2011, what is the difference between the Active population (% of total population) in High income and Active population (% of total population) in Mongolia?
Your answer should be very brief. -1.28. In the year 2011, what is the difference between the Active population (% of total population) in Bosnia and Herzegovina and Active population (% of total population) in Lithuania?
Offer a very short reply. -19.9. In the year 2011, what is the difference between the Active population (% of total population) in Bosnia and Herzegovina and Active population (% of total population) in Mongolia?
Keep it short and to the point. -22.2. In the year 2012, what is the difference between the Active population (% of total population) of High income and Active population (% of total population) of Bosnia and Herzegovina?
Your response must be concise. 21.3. In the year 2012, what is the difference between the Active population (% of total population) of High income and Active population (% of total population) of Lithuania?
Provide a short and direct response. 0.6. In the year 2012, what is the difference between the Active population (% of total population) of High income and Active population (% of total population) of Mongolia?
Provide a short and direct response. -4.6. In the year 2012, what is the difference between the Active population (% of total population) in Bosnia and Herzegovina and Active population (% of total population) in Lithuania?
Give a very brief answer. -20.7. In the year 2012, what is the difference between the Active population (% of total population) of Bosnia and Herzegovina and Active population (% of total population) of Mongolia?
Provide a short and direct response. -25.9. In the year 2013, what is the difference between the Active population (% of total population) of High income and Active population (% of total population) of Bosnia and Herzegovina?
Ensure brevity in your answer.  21.35. In the year 2013, what is the difference between the Active population (% of total population) of High income and Active population (% of total population) of Lithuania?
Offer a very short reply. 0.95. In the year 2013, what is the difference between the Active population (% of total population) in High income and Active population (% of total population) in Mongolia?
Your answer should be very brief. -2.45. In the year 2013, what is the difference between the Active population (% of total population) in Bosnia and Herzegovina and Active population (% of total population) in Lithuania?
Offer a very short reply. -20.4. In the year 2013, what is the difference between the Active population (% of total population) in Bosnia and Herzegovina and Active population (% of total population) in Mongolia?
Give a very brief answer. -23.8. In the year 2013, what is the difference between the Active population (% of total population) of Lithuania and Active population (% of total population) of Mongolia?
Offer a very short reply. -3.4. What is the ratio of the Active population (% of total population) of High income in 2006 to that in 2007?
Your answer should be compact. 1. What is the ratio of the Active population (% of total population) in Mongolia in 2006 to that in 2007?
Your answer should be compact. 1.15. What is the ratio of the Active population (% of total population) of High income in 2006 to that in 2008?
Offer a very short reply. 0.99. What is the ratio of the Active population (% of total population) of Bosnia and Herzegovina in 2006 to that in 2008?
Ensure brevity in your answer.  0.97. What is the ratio of the Active population (% of total population) in Lithuania in 2006 to that in 2008?
Make the answer very short. 0.99. What is the ratio of the Active population (% of total population) in Mongolia in 2006 to that in 2008?
Your answer should be very brief. 1.19. What is the ratio of the Active population (% of total population) in High income in 2006 to that in 2009?
Provide a succinct answer. 0.99. What is the ratio of the Active population (% of total population) in Bosnia and Herzegovina in 2006 to that in 2009?
Keep it short and to the point. 0.97. What is the ratio of the Active population (% of total population) in Lithuania in 2006 to that in 2009?
Offer a very short reply. 0.97. What is the ratio of the Active population (% of total population) of Mongolia in 2006 to that in 2009?
Provide a succinct answer. 1.2. What is the ratio of the Active population (% of total population) of High income in 2006 to that in 2010?
Ensure brevity in your answer.  0.98. What is the ratio of the Active population (% of total population) in Bosnia and Herzegovina in 2006 to that in 2010?
Provide a short and direct response. 0.93. What is the ratio of the Active population (% of total population) of Lithuania in 2006 to that in 2010?
Ensure brevity in your answer.  0.96. What is the ratio of the Active population (% of total population) of Mongolia in 2006 to that in 2010?
Provide a succinct answer. 1.18. What is the ratio of the Active population (% of total population) in High income in 2006 to that in 2011?
Ensure brevity in your answer.  0.99. What is the ratio of the Active population (% of total population) in Bosnia and Herzegovina in 2006 to that in 2011?
Your answer should be compact. 0.94. What is the ratio of the Active population (% of total population) in Lithuania in 2006 to that in 2011?
Your answer should be very brief. 0.95. What is the ratio of the Active population (% of total population) of Mongolia in 2006 to that in 2011?
Give a very brief answer. 1.17. What is the ratio of the Active population (% of total population) in High income in 2006 to that in 2012?
Provide a succinct answer. 0.99. What is the ratio of the Active population (% of total population) in Bosnia and Herzegovina in 2006 to that in 2012?
Your answer should be very brief. 0.95. What is the ratio of the Active population (% of total population) in Lithuania in 2006 to that in 2012?
Make the answer very short. 0.94. What is the ratio of the Active population (% of total population) in Mongolia in 2006 to that in 2012?
Your answer should be very brief. 1.1. What is the ratio of the Active population (% of total population) in High income in 2006 to that in 2013?
Your answer should be compact. 0.99. What is the ratio of the Active population (% of total population) in Bosnia and Herzegovina in 2006 to that in 2013?
Provide a short and direct response. 0.95. What is the ratio of the Active population (% of total population) of Lithuania in 2006 to that in 2013?
Offer a very short reply. 0.95. What is the ratio of the Active population (% of total population) of Mongolia in 2006 to that in 2013?
Provide a succinct answer. 1.14. What is the ratio of the Active population (% of total population) of High income in 2007 to that in 2008?
Your answer should be very brief. 1. What is the ratio of the Active population (% of total population) of Bosnia and Herzegovina in 2007 to that in 2008?
Provide a short and direct response. 0.98. What is the ratio of the Active population (% of total population) of Mongolia in 2007 to that in 2008?
Offer a very short reply. 1.03. What is the ratio of the Active population (% of total population) in Bosnia and Herzegovina in 2007 to that in 2009?
Ensure brevity in your answer.  0.97. What is the ratio of the Active population (% of total population) of Lithuania in 2007 to that in 2009?
Provide a succinct answer. 0.97. What is the ratio of the Active population (% of total population) in Mongolia in 2007 to that in 2009?
Offer a terse response. 1.04. What is the ratio of the Active population (% of total population) in Bosnia and Herzegovina in 2007 to that in 2010?
Make the answer very short. 0.93. What is the ratio of the Active population (% of total population) of Lithuania in 2007 to that in 2010?
Provide a succinct answer. 0.96. What is the ratio of the Active population (% of total population) in Mongolia in 2007 to that in 2010?
Make the answer very short. 1.03. What is the ratio of the Active population (% of total population) of High income in 2007 to that in 2011?
Provide a short and direct response. 0.99. What is the ratio of the Active population (% of total population) in Bosnia and Herzegovina in 2007 to that in 2011?
Your answer should be compact. 0.95. What is the ratio of the Active population (% of total population) in Lithuania in 2007 to that in 2011?
Make the answer very short. 0.95. What is the ratio of the Active population (% of total population) in Mongolia in 2007 to that in 2011?
Your answer should be compact. 1.01. What is the ratio of the Active population (% of total population) of High income in 2007 to that in 2012?
Your answer should be very brief. 0.99. What is the ratio of the Active population (% of total population) in Bosnia and Herzegovina in 2007 to that in 2012?
Provide a succinct answer. 0.95. What is the ratio of the Active population (% of total population) in Lithuania in 2007 to that in 2012?
Keep it short and to the point. 0.94. What is the ratio of the Active population (% of total population) of Mongolia in 2007 to that in 2012?
Your answer should be compact. 0.95. What is the ratio of the Active population (% of total population) of High income in 2007 to that in 2013?
Ensure brevity in your answer.  0.99. What is the ratio of the Active population (% of total population) in Bosnia and Herzegovina in 2007 to that in 2013?
Make the answer very short. 0.95. What is the ratio of the Active population (% of total population) of Lithuania in 2007 to that in 2013?
Offer a very short reply. 0.95. What is the ratio of the Active population (% of total population) of Mongolia in 2007 to that in 2013?
Your answer should be very brief. 0.99. What is the ratio of the Active population (% of total population) in High income in 2008 to that in 2009?
Make the answer very short. 1. What is the ratio of the Active population (% of total population) of Bosnia and Herzegovina in 2008 to that in 2009?
Your answer should be compact. 0.99. What is the ratio of the Active population (% of total population) in Lithuania in 2008 to that in 2009?
Make the answer very short. 0.97. What is the ratio of the Active population (% of total population) of Mongolia in 2008 to that in 2009?
Your answer should be very brief. 1.01. What is the ratio of the Active population (% of total population) of High income in 2008 to that in 2010?
Ensure brevity in your answer.  0.99. What is the ratio of the Active population (% of total population) in Bosnia and Herzegovina in 2008 to that in 2010?
Offer a terse response. 0.95. What is the ratio of the Active population (% of total population) in Lithuania in 2008 to that in 2010?
Your answer should be compact. 0.96. What is the ratio of the Active population (% of total population) of High income in 2008 to that in 2011?
Your answer should be very brief. 1. What is the ratio of the Active population (% of total population) of Bosnia and Herzegovina in 2008 to that in 2011?
Keep it short and to the point. 0.97. What is the ratio of the Active population (% of total population) of Mongolia in 2008 to that in 2011?
Your response must be concise. 0.98. What is the ratio of the Active population (% of total population) of High income in 2008 to that in 2012?
Your answer should be compact. 1. What is the ratio of the Active population (% of total population) in Bosnia and Herzegovina in 2008 to that in 2012?
Offer a terse response. 0.98. What is the ratio of the Active population (% of total population) of Lithuania in 2008 to that in 2012?
Keep it short and to the point. 0.95. What is the ratio of the Active population (% of total population) in Mongolia in 2008 to that in 2012?
Offer a very short reply. 0.93. What is the ratio of the Active population (% of total population) of High income in 2008 to that in 2013?
Give a very brief answer. 0.99. What is the ratio of the Active population (% of total population) in Bosnia and Herzegovina in 2008 to that in 2013?
Your answer should be very brief. 0.98. What is the ratio of the Active population (% of total population) in Lithuania in 2008 to that in 2013?
Your answer should be compact. 0.95. What is the ratio of the Active population (% of total population) of Mongolia in 2008 to that in 2013?
Give a very brief answer. 0.96. What is the ratio of the Active population (% of total population) of Bosnia and Herzegovina in 2009 to that in 2010?
Provide a succinct answer. 0.96. What is the ratio of the Active population (% of total population) in Lithuania in 2009 to that in 2010?
Give a very brief answer. 0.99. What is the ratio of the Active population (% of total population) of Mongolia in 2009 to that in 2010?
Give a very brief answer. 0.99. What is the ratio of the Active population (% of total population) of High income in 2009 to that in 2011?
Provide a short and direct response. 1. What is the ratio of the Active population (% of total population) in Bosnia and Herzegovina in 2009 to that in 2011?
Provide a short and direct response. 0.97. What is the ratio of the Active population (% of total population) in Lithuania in 2009 to that in 2011?
Provide a short and direct response. 0.99. What is the ratio of the Active population (% of total population) of Mongolia in 2009 to that in 2011?
Give a very brief answer. 0.98. What is the ratio of the Active population (% of total population) in High income in 2009 to that in 2012?
Your answer should be compact. 1. What is the ratio of the Active population (% of total population) of Bosnia and Herzegovina in 2009 to that in 2012?
Offer a very short reply. 0.98. What is the ratio of the Active population (% of total population) of Lithuania in 2009 to that in 2012?
Your response must be concise. 0.98. What is the ratio of the Active population (% of total population) in Mongolia in 2009 to that in 2012?
Provide a succinct answer. 0.92. What is the ratio of the Active population (% of total population) in High income in 2009 to that in 2013?
Provide a succinct answer. 1. What is the ratio of the Active population (% of total population) of Bosnia and Herzegovina in 2009 to that in 2013?
Offer a very short reply. 0.98. What is the ratio of the Active population (% of total population) of Lithuania in 2009 to that in 2013?
Make the answer very short. 0.98. What is the ratio of the Active population (% of total population) in Mongolia in 2009 to that in 2013?
Keep it short and to the point. 0.96. What is the ratio of the Active population (% of total population) of High income in 2010 to that in 2011?
Your answer should be very brief. 1.01. What is the ratio of the Active population (% of total population) in Bosnia and Herzegovina in 2010 to that in 2011?
Offer a terse response. 1.01. What is the ratio of the Active population (% of total population) of Mongolia in 2010 to that in 2011?
Offer a terse response. 0.99. What is the ratio of the Active population (% of total population) of Bosnia and Herzegovina in 2010 to that in 2012?
Give a very brief answer. 1.02. What is the ratio of the Active population (% of total population) of Mongolia in 2010 to that in 2012?
Give a very brief answer. 0.93. What is the ratio of the Active population (% of total population) of High income in 2010 to that in 2013?
Give a very brief answer. 1.01. What is the ratio of the Active population (% of total population) of Bosnia and Herzegovina in 2010 to that in 2013?
Offer a terse response. 1.02. What is the ratio of the Active population (% of total population) in Mongolia in 2010 to that in 2013?
Offer a terse response. 0.96. What is the ratio of the Active population (% of total population) of High income in 2011 to that in 2012?
Offer a terse response. 1. What is the ratio of the Active population (% of total population) of Bosnia and Herzegovina in 2011 to that in 2012?
Ensure brevity in your answer.  1.01. What is the ratio of the Active population (% of total population) of Lithuania in 2011 to that in 2012?
Ensure brevity in your answer.  0.99. What is the ratio of the Active population (% of total population) of Mongolia in 2011 to that in 2012?
Ensure brevity in your answer.  0.94. What is the ratio of the Active population (% of total population) in High income in 2011 to that in 2013?
Provide a succinct answer. 1. What is the ratio of the Active population (% of total population) of Bosnia and Herzegovina in 2011 to that in 2013?
Your answer should be compact. 1.01. What is the ratio of the Active population (% of total population) of Lithuania in 2011 to that in 2013?
Provide a succinct answer. 1. What is the ratio of the Active population (% of total population) of Mongolia in 2011 to that in 2013?
Your answer should be very brief. 0.98. What is the ratio of the Active population (% of total population) of Mongolia in 2012 to that in 2013?
Your answer should be very brief. 1.04. What is the difference between the highest and the second highest Active population (% of total population) of High income?
Make the answer very short. 0.28. What is the difference between the highest and the second highest Active population (% of total population) of Bosnia and Herzegovina?
Ensure brevity in your answer.  0.4. What is the difference between the highest and the second highest Active population (% of total population) in Lithuania?
Your response must be concise. 0.3. What is the difference between the highest and the lowest Active population (% of total population) in High income?
Your response must be concise. 0.82. What is the difference between the highest and the lowest Active population (% of total population) of Bosnia and Herzegovina?
Ensure brevity in your answer.  2.4. 